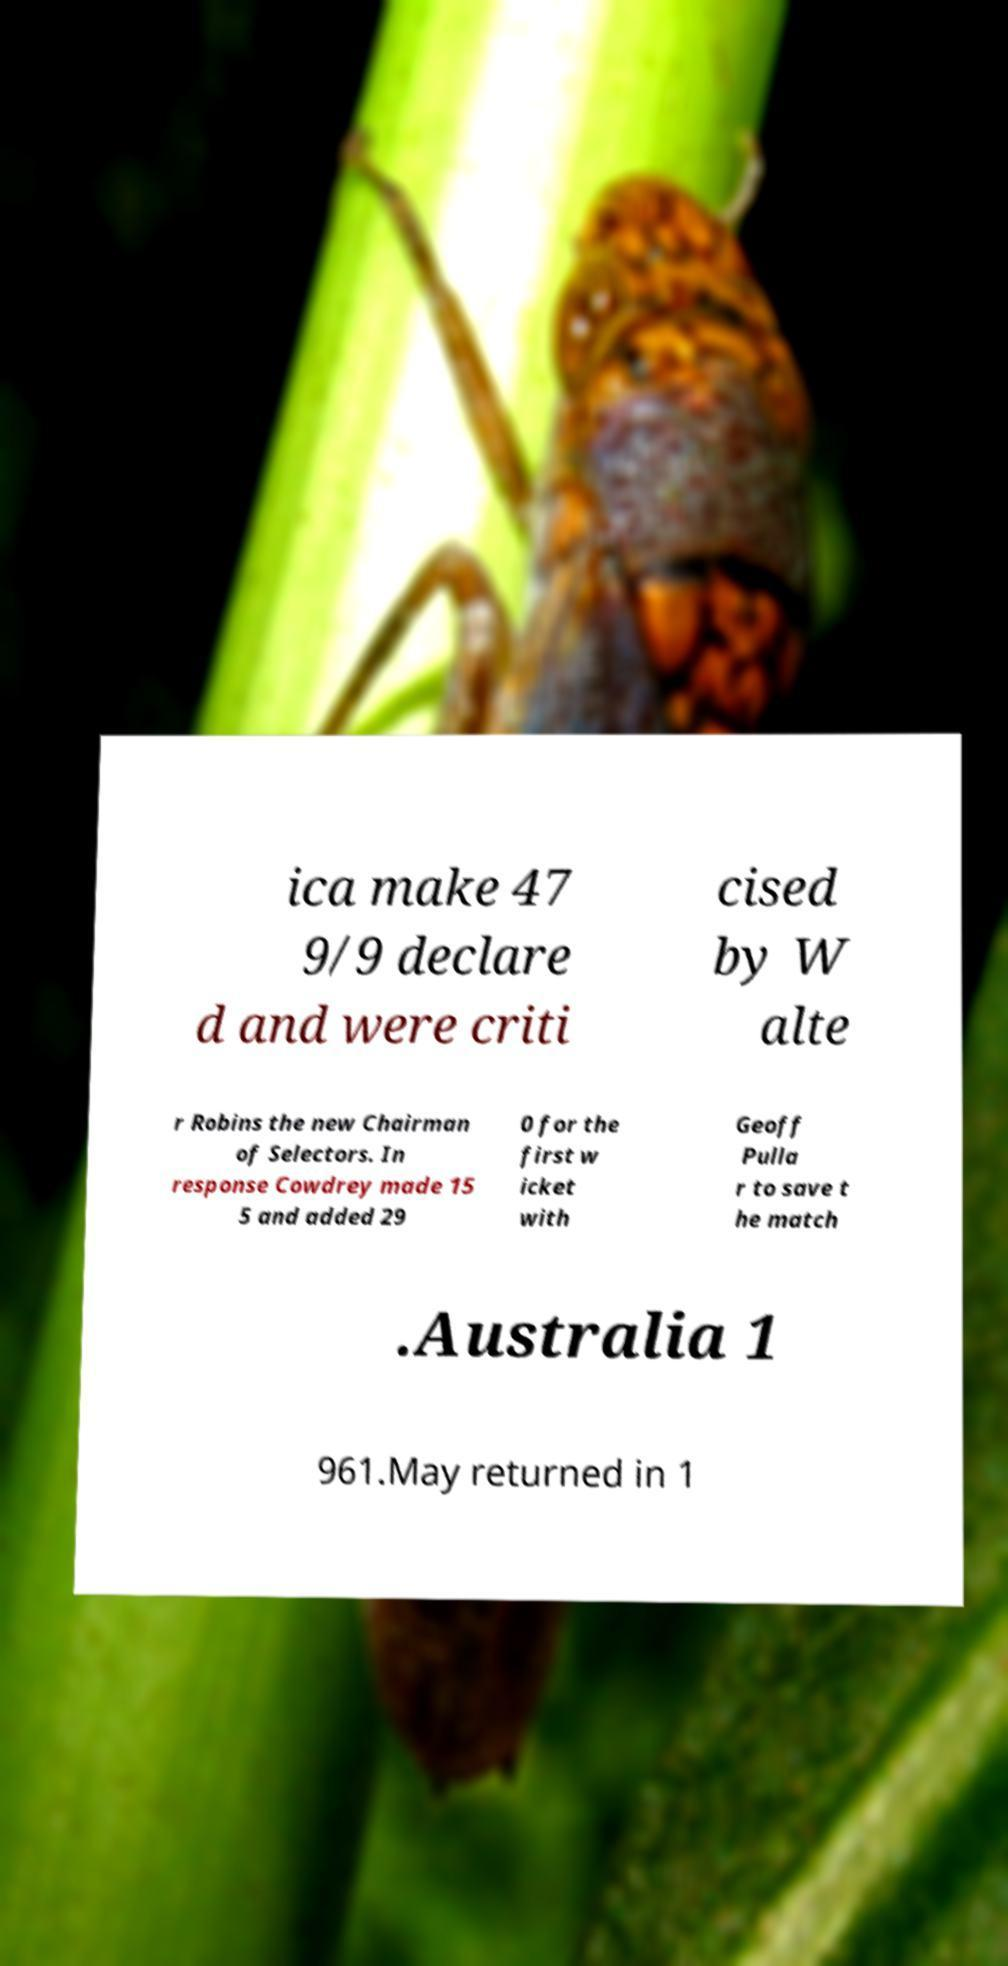There's text embedded in this image that I need extracted. Can you transcribe it verbatim? ica make 47 9/9 declare d and were criti cised by W alte r Robins the new Chairman of Selectors. In response Cowdrey made 15 5 and added 29 0 for the first w icket with Geoff Pulla r to save t he match .Australia 1 961.May returned in 1 